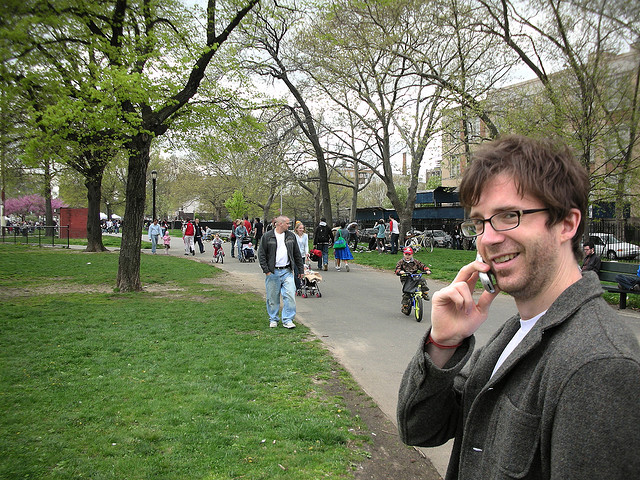<image>What kind of blossoms are on the tree? There may not be any blossoms on the tree. However if there are, they could be pink or cherry blossoms. What kind of blossoms are on the tree? I am not sure what kind of blossoms are on the tree. There are some pink and cherry blossoms, but also some other types. 